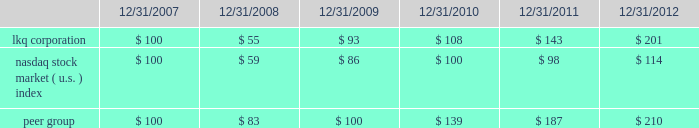Comparison of cumulative return among lkq corporation , the nasdaq stock market ( u.s. ) index and the peer group .
This stock performance information is "furnished" and shall not be deemed to be "soliciting material" or subject to rule 14a , shall not be deemed "filed" for purposes of section 18 of the securities exchange act of 1934 or otherwise subject to the liabilities of that section , and shall not be deemed incorporated by reference in any filing under the securities act of 1933 or the securities exchange act of 1934 , whether made before or after the date of this report and irrespective of any general incorporation by reference language in any such filing , except to the extent that it specifically incorporates the information by reference .
Information about our common stock that may be issued under our equity compensation plans as of december 31 , 2012 included in part iii , item 12 of this annual report on form 10-k is incorporated herein by reference. .
Based on the review of the comparison of the cumulative return among lkq corporation , what was the performance ratio the nasdaq stock to the lqk corporation in 2018? 
Computations: (98 / 143)
Answer: 0.68531. 